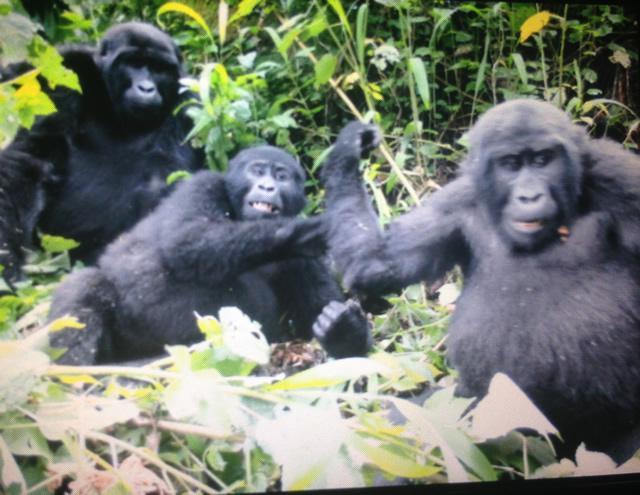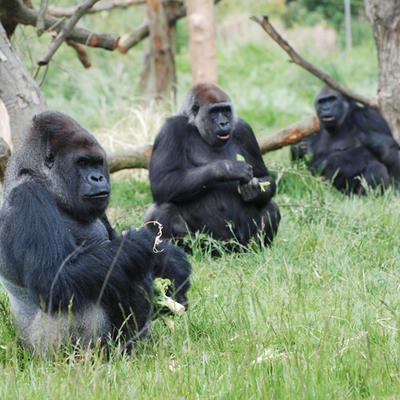The first image is the image on the left, the second image is the image on the right. Given the left and right images, does the statement "The left and right image contains the same number of real breathing gorillas." hold true? Answer yes or no. Yes. The first image is the image on the left, the second image is the image on the right. Considering the images on both sides, is "There are six gorillas tht are sitting" valid? Answer yes or no. Yes. 